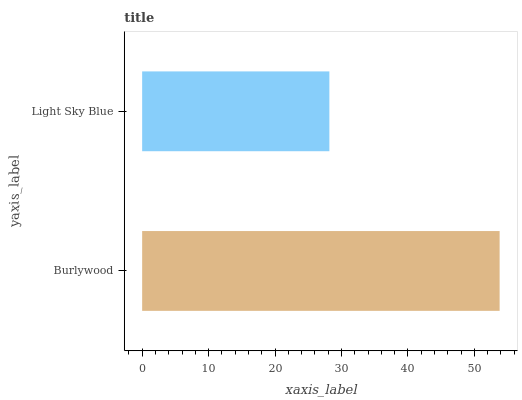Is Light Sky Blue the minimum?
Answer yes or no. Yes. Is Burlywood the maximum?
Answer yes or no. Yes. Is Light Sky Blue the maximum?
Answer yes or no. No. Is Burlywood greater than Light Sky Blue?
Answer yes or no. Yes. Is Light Sky Blue less than Burlywood?
Answer yes or no. Yes. Is Light Sky Blue greater than Burlywood?
Answer yes or no. No. Is Burlywood less than Light Sky Blue?
Answer yes or no. No. Is Burlywood the high median?
Answer yes or no. Yes. Is Light Sky Blue the low median?
Answer yes or no. Yes. Is Light Sky Blue the high median?
Answer yes or no. No. Is Burlywood the low median?
Answer yes or no. No. 